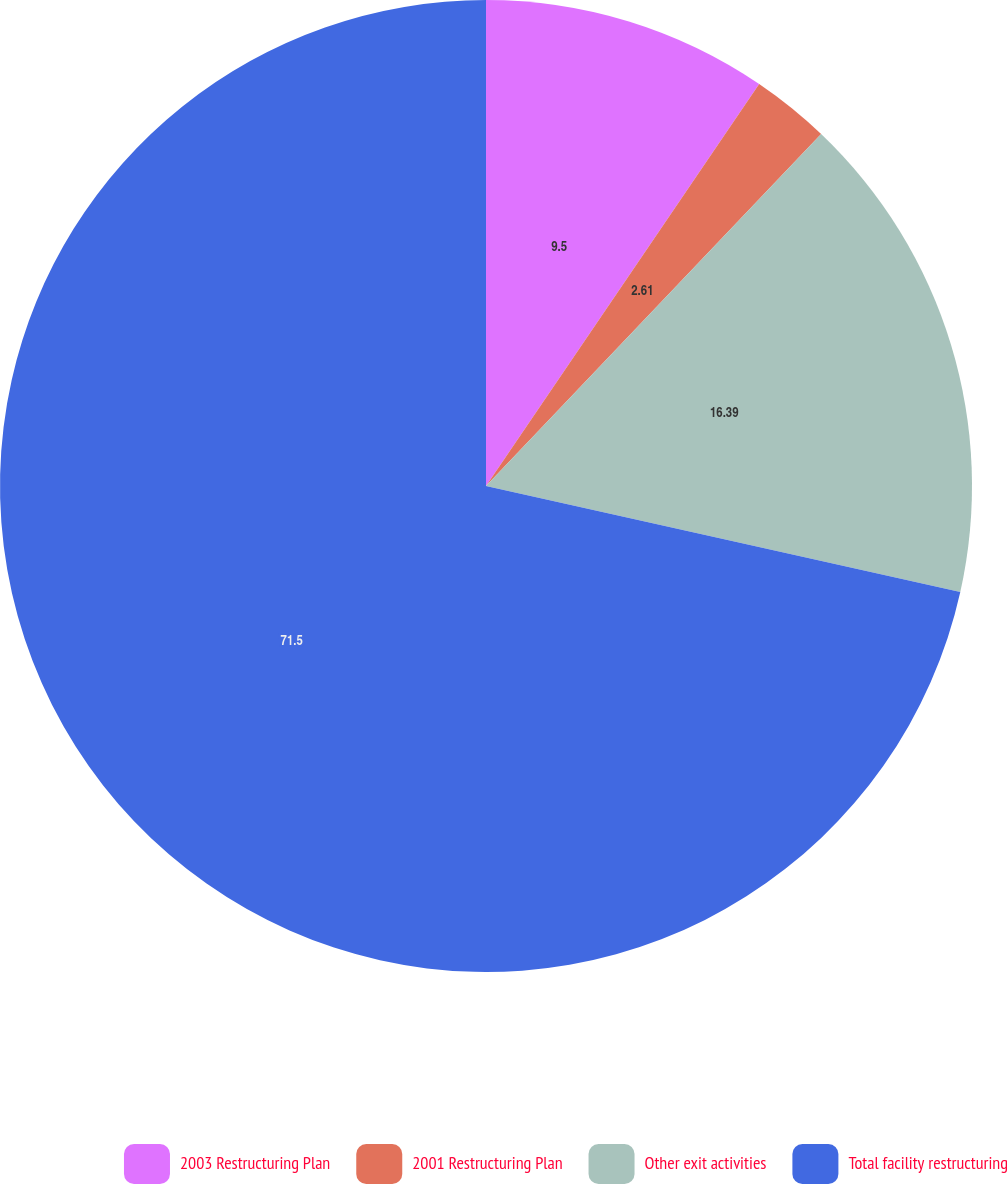Convert chart. <chart><loc_0><loc_0><loc_500><loc_500><pie_chart><fcel>2003 Restructuring Plan<fcel>2001 Restructuring Plan<fcel>Other exit activities<fcel>Total facility restructuring<nl><fcel>9.5%<fcel>2.61%<fcel>16.39%<fcel>71.5%<nl></chart> 